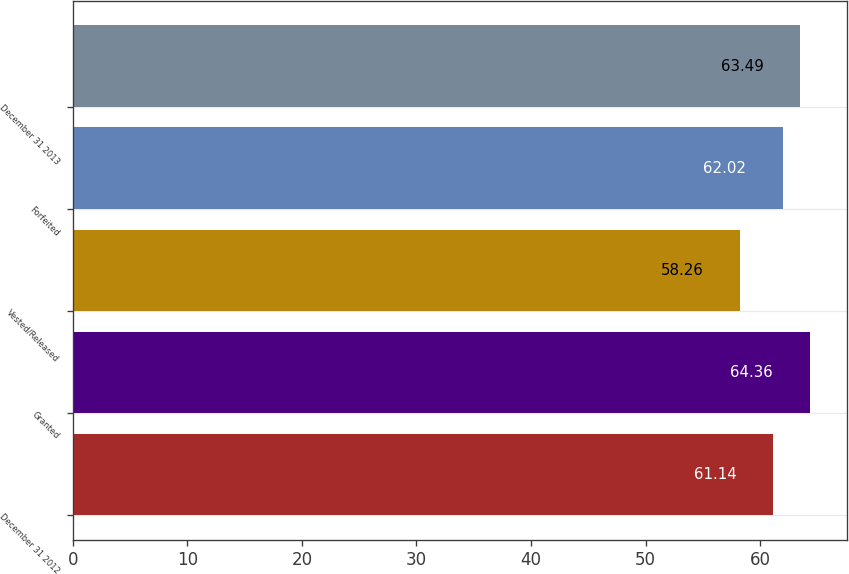Convert chart to OTSL. <chart><loc_0><loc_0><loc_500><loc_500><bar_chart><fcel>December 31 2012<fcel>Granted<fcel>Vested/Released<fcel>Forfeited<fcel>December 31 2013<nl><fcel>61.14<fcel>64.36<fcel>58.26<fcel>62.02<fcel>63.49<nl></chart> 